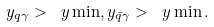Convert formula to latex. <formula><loc_0><loc_0><loc_500><loc_500>y _ { q \gamma } > \ y \min , y _ { \bar { q } \gamma } > \ y \min .</formula> 